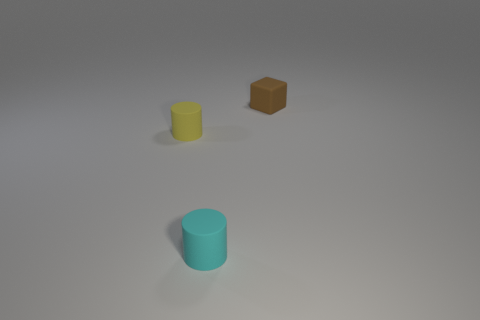What number of things are matte objects or cyan objects?
Provide a succinct answer. 3. There is a matte cylinder that is the same size as the cyan matte object; what color is it?
Give a very brief answer. Yellow. How many things are either small things right of the small cyan rubber cylinder or small cyan things in front of the block?
Your answer should be very brief. 2. Is the number of cyan things that are behind the small cyan cylinder the same as the number of tiny gray metal blocks?
Keep it short and to the point. Yes. There is a rubber object that is right of the cyan cylinder; is it the same size as the rubber cylinder in front of the tiny yellow cylinder?
Your answer should be very brief. Yes. What number of other objects are the same size as the yellow rubber cylinder?
Keep it short and to the point. 2. There is a small matte thing in front of the matte cylinder left of the cyan matte cylinder; is there a tiny yellow matte cylinder in front of it?
Your response must be concise. No. Are there any other things of the same color as the small cube?
Provide a succinct answer. No. There is a rubber object left of the cyan matte object; how big is it?
Provide a short and direct response. Small. There is a brown thing on the right side of the matte cylinder that is on the right side of the matte cylinder that is left of the small cyan matte cylinder; what is its size?
Your answer should be very brief. Small. 